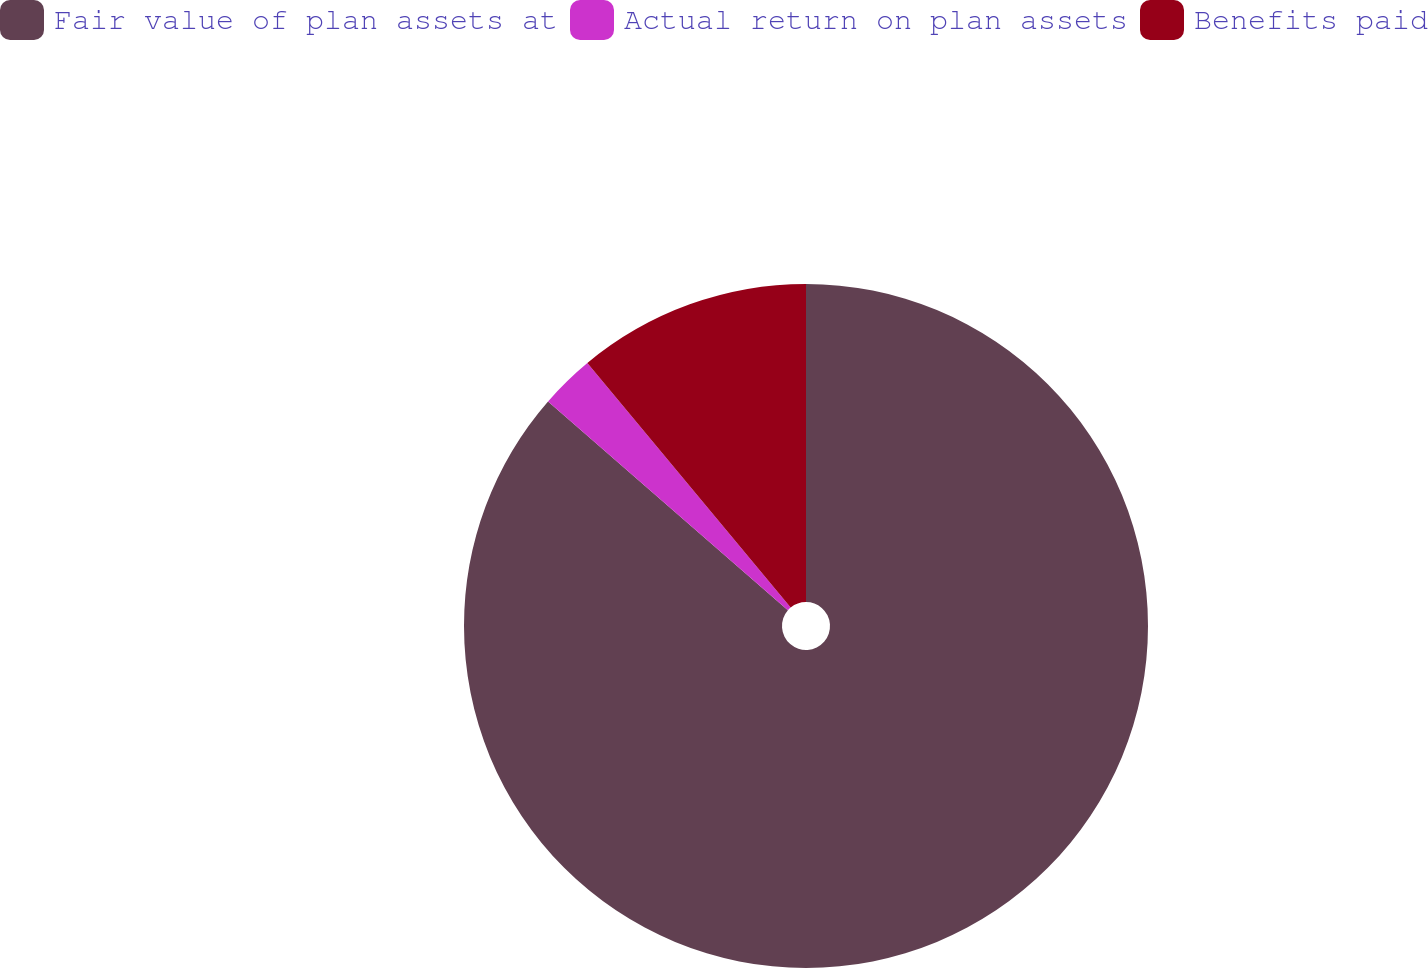Convert chart to OTSL. <chart><loc_0><loc_0><loc_500><loc_500><pie_chart><fcel>Fair value of plan assets at<fcel>Actual return on plan assets<fcel>Benefits paid<nl><fcel>86.4%<fcel>2.56%<fcel>11.04%<nl></chart> 